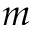<formula> <loc_0><loc_0><loc_500><loc_500>m</formula> 